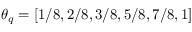<formula> <loc_0><loc_0><loc_500><loc_500>\theta _ { q } = [ 1 / 8 , 2 / 8 , 3 / 8 , 5 / 8 , 7 / 8 , 1 ]</formula> 